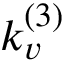<formula> <loc_0><loc_0><loc_500><loc_500>k _ { v } ^ { ( 3 ) }</formula> 